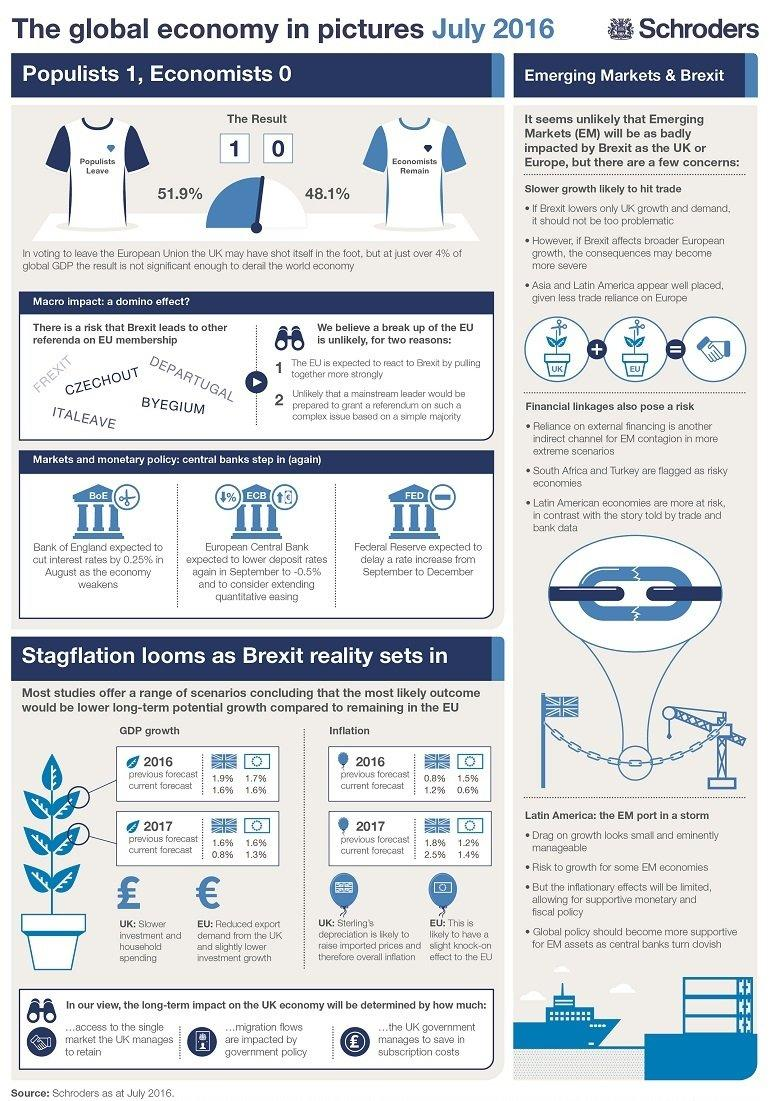Give some essential details in this illustration. The Federal Reserve is expected to delay a rate increase from September to December due to the uncertainty surrounding the global economic outlook and the ongoing trade tensions between the United States and other countries. The decision to leave the European Union, which was supported by 51.9% of the UK population, was made through a popular vote. According to the vote, 48.1% of the UK population believed that the country should not leave the EU. The European Central Bank is expected to lower deposit rates. The forecast for GDP growth in 2016 for the UK is 1.6%. 